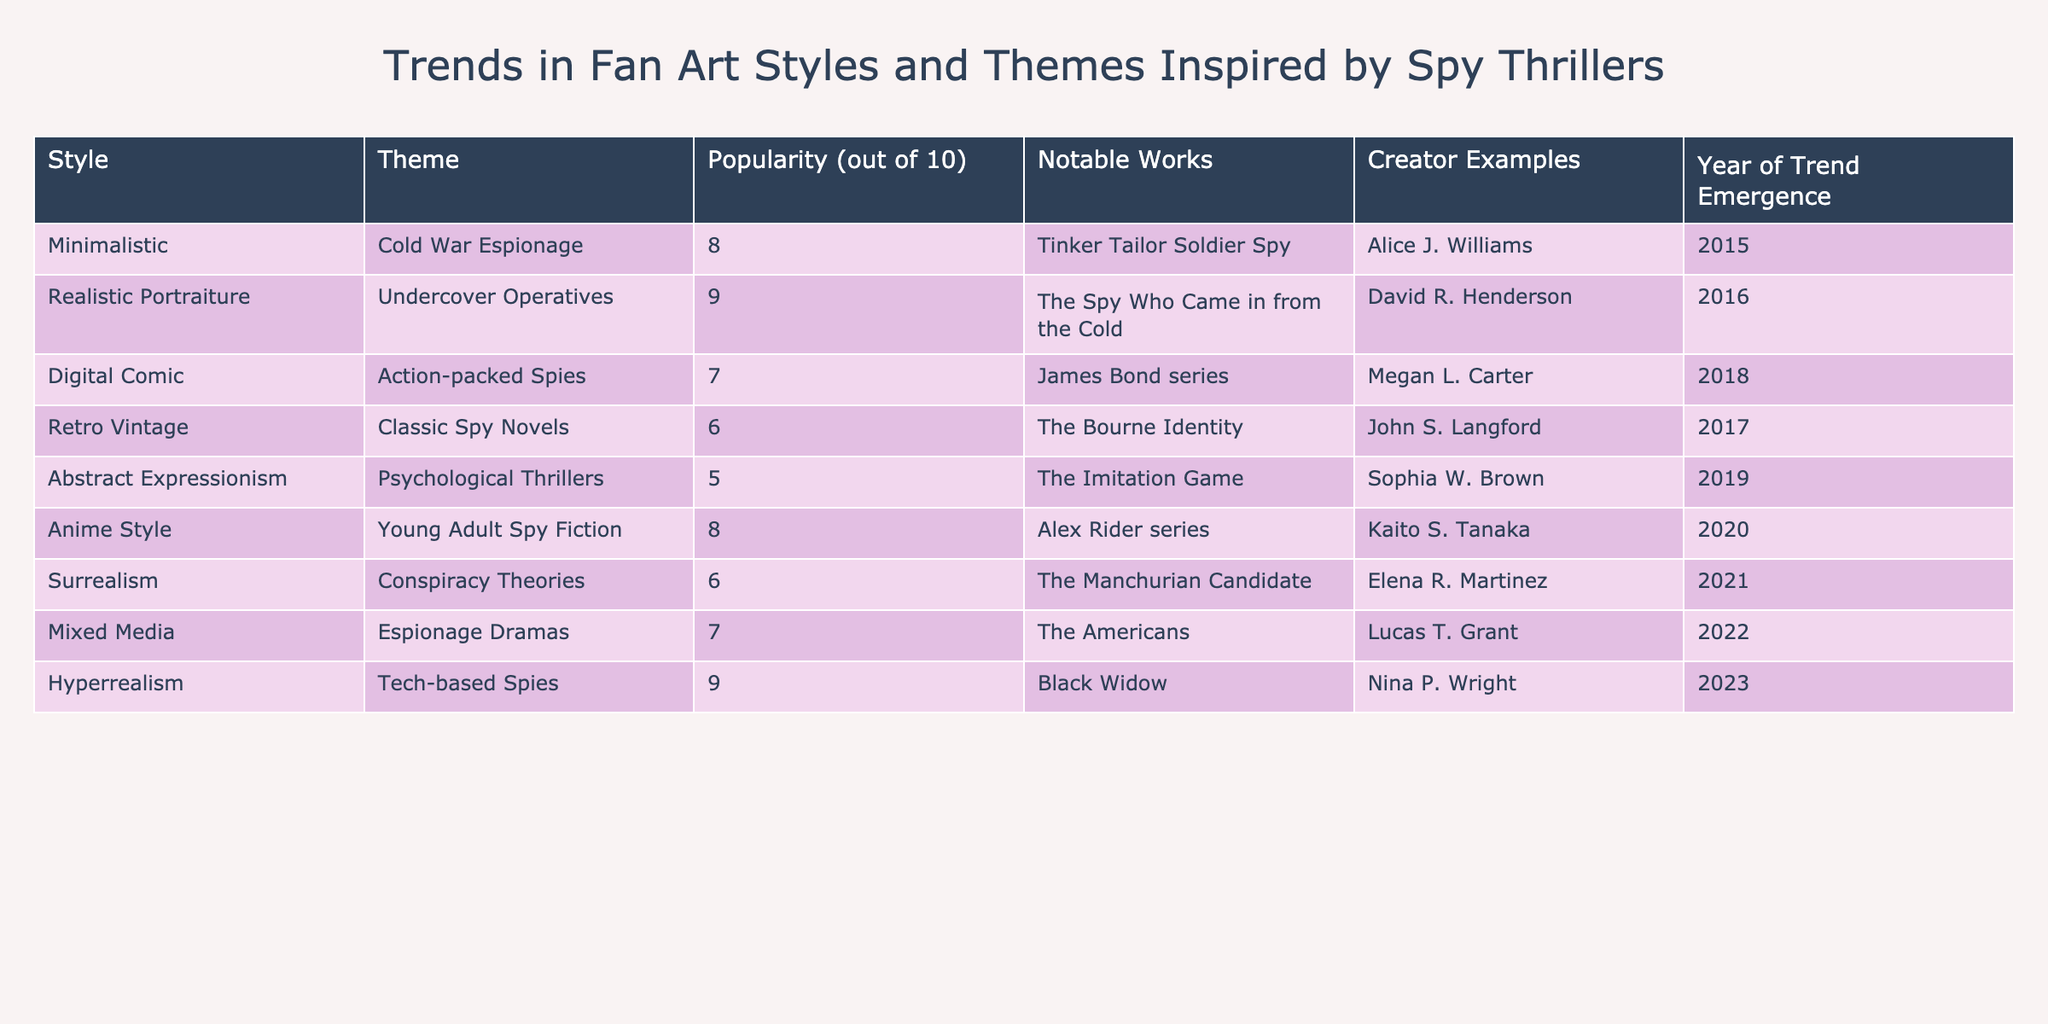What is the most popular fan art style based on the table? The table shows the "Popularity" column, and by checking the values, "Realistic Portraiture" has the highest score of 9.
Answer: Realistic Portraiture How many fan art styles have a popularity rating of 7 or higher? Upon counting the styles listed with a popularity rating of 7 or higher, we find that "Realistic Portraiture" (9), "Anime Style" (8), "Cold War Espionage" (8), and "Hyperrealism" (9) fit the criteria. This gives us a total of 4 styles.
Answer: 4 Which creator has worked on a fan art style associated with "Tech-based Spies"? Looking at the "Theme" column for "Tech-based Spies," we can identify that "Hyperrealism" is the associated style, and the creator listed for this style is Nina P. Wright.
Answer: Nina P. Wright Is there a fan art style associated with "Conspiracy Theories" that has a popularity rating above 5? The table shows that "Surrealism," which is the style linked to "Conspiracy Theories," has a popularity rating of 6. Therefore, the statement is true as it meets the criteria.
Answer: Yes What is the average popularity rating of the fan art styles listed in the table? To find the average, we first sum the popularity ratings: 8 + 9 + 7 + 6 + 5 + 8 + 6 + 7 + 9 = 66. There are 9 styles, so we compute the average as 66 divided by 9, which equals approximately 7.33.
Answer: 7.33 Which notable work corresponds to the "Cold War Espionage" theme? The table lists "Tinker Tailor Soldier Spy" as the notable work associated with the "Cold War Espionage" theme, as indicated in the corresponding row.
Answer: Tinker Tailor Soldier Spy Is "Mixed Media" more popular than "Digital Comic"? Comparing the popularity ratings, "Mixed Media" has a rating of 7, while "Digital Comic" has a rating of 7. Therefore, they are equal, and the statement is false.
Answer: No What year did "Anime Style" trend emerge, and how does its popularity compare with "Abstract Expressionism"? "Anime Style" emerged in 2020 with a popularity rating of 8, and "Abstract Expressionism" emerged in 2019 with a popularity rating of 5. Since 8 is greater than 5, we can confirm that "Anime Style" is more popular.
Answer: 2020, more popular than Abstract Expressionism 